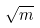<formula> <loc_0><loc_0><loc_500><loc_500>\sqrt { m }</formula> 